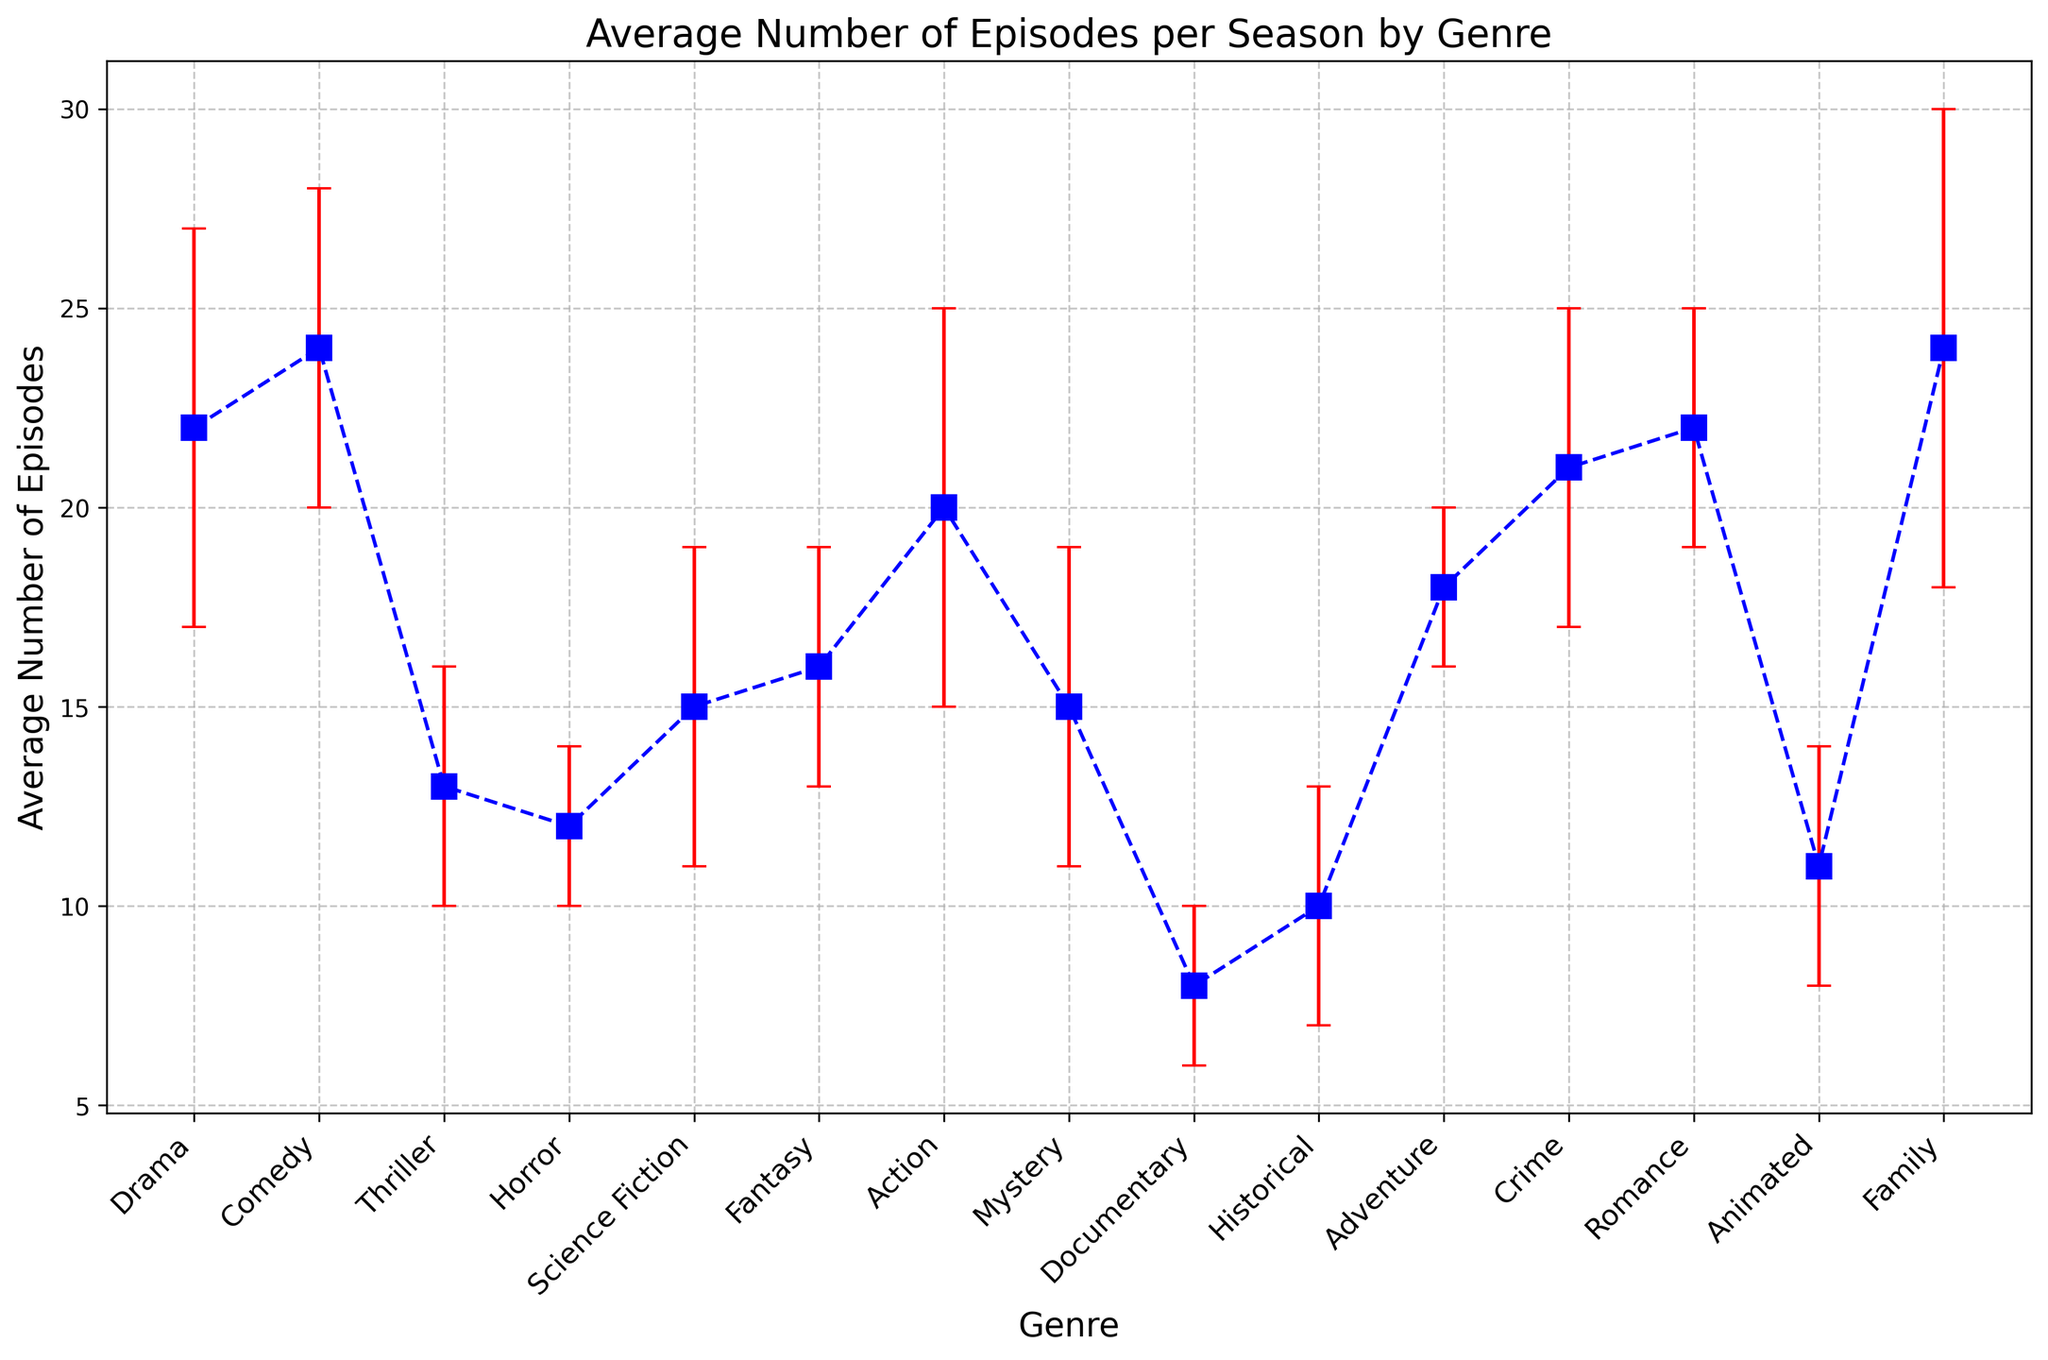Which genre has the highest average number of episodes per season? The plot shows data points for each genre along with their average number of episodes. A quick glance at the height of the markers indicates that Comedy and Family are the highest, both at 24 episodes per season.
Answer: Comedy and Family Which genre has the lowest average number of episodes per season? By visually inspecting the chart, the Documentary genre appears to have the lowest height among all the markers, showing an average of 8 episodes per season.
Answer: Documentary How many more average episodes does Drama have compared to Thriller? Drama has an average of 22 episodes, and Thriller has an average of 13 episodes. Subtract the average of Thriller from Drama to find the difference: 22 - 13.
Answer: 9 Which genres have an average number of episodes within the error margin of 2? In the plot, the error bars show the range of average episodes ± standard deviation. Visually, Horror (12 ± 2) and Adventure (18 ± 2) have error margins that span 2 episodes.
Answer: Horror, Adventure What is the average difference in episode count between Science Fiction and Fantasy? Science Fiction averages 15 episodes, and Fantasy averages 16 episodes. The difference is the absolute value of 15 - 16.
Answer: 1 Compare the average number of episodes between Comedy and Romance. Are they equal? The plot shows data markers for Comedy and Romance, both with an average of 24 episodes.
Answer: Yes What is the range of average episodes for Family compared to Historical? Family has an average of 24 episodes with a standard deviation of 6 (so a range of 18 to 30), while Historical has an average of 10 with a standard deviation of 3 (so a range of 7 to 13).
Answer: Family: 18 to 30, Historical: 7 to 13 Which genre has a similar average episode count to Action? By inspecting the plot, Action has an average of 20 episodes. Crime also has a similar count with an average of 21 episodes.
Answer: Crime Is there any genre where the average and standard deviation create a maximum range exceeding 30 episodes? By inspecting the plot, Family is the genre with an average of 24 episodes and a standard deviation of 6, which gives a range up to 30 (24 + 6). There’s no genre exceeding this range when considering average and standard deviation.
Answer: No Describe the episode count distribution among genres with an average of 15 episodes. Science Fiction, Mystery, and Thriller all cluster around 15 episodes. Science Fiction and Mystery both have ±4 standard deviation, whereas Thriller has ±3.
Answer: Science Fiction, Mystery 